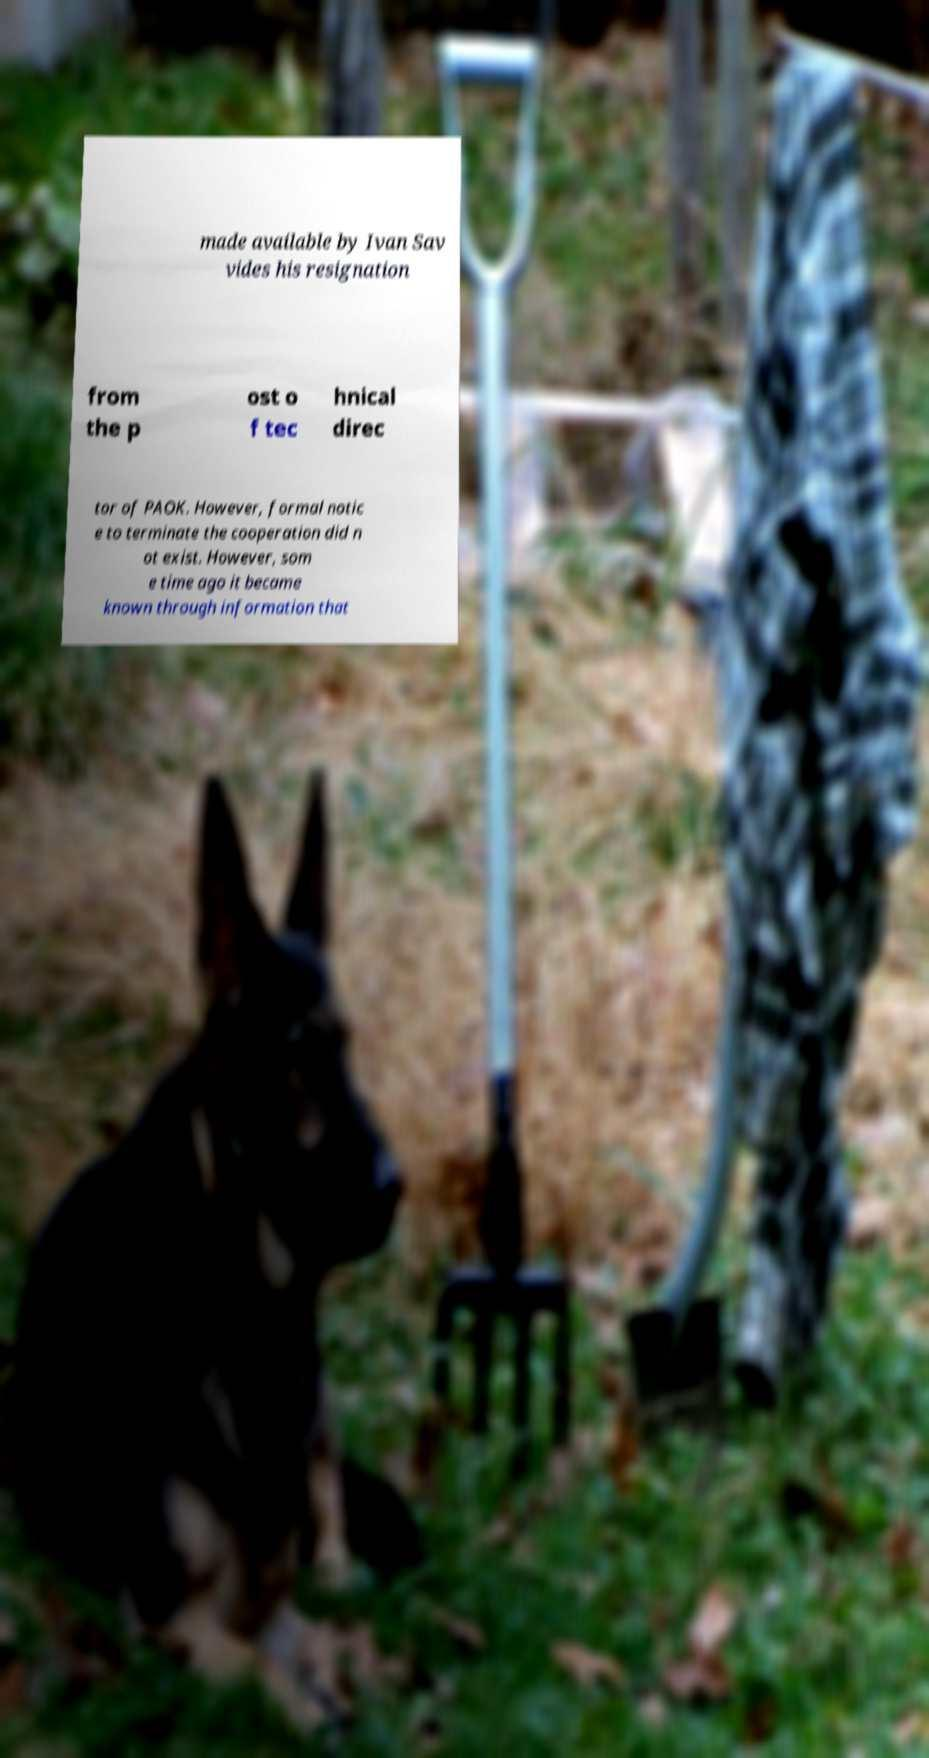What does the presence of the German Shepherd in the image suggest about the atmosphere or theme? The German Shepherd sitting attentively next to the paper could suggest themes of loyalty, protection, or vigilance. This breeds’ characteristics might metaphorically align with the theme of protecting or guarding the information disclosed in the text, possibly indicating a narrative of loyalty or careful oversight in a corporate or personal setting. 